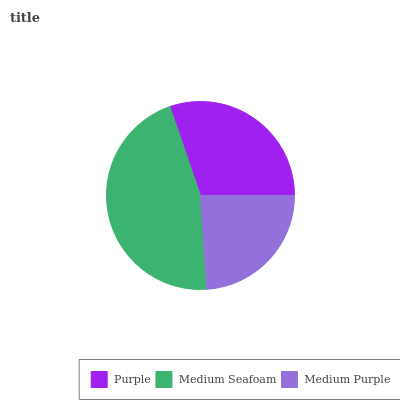Is Medium Purple the minimum?
Answer yes or no. Yes. Is Medium Seafoam the maximum?
Answer yes or no. Yes. Is Medium Seafoam the minimum?
Answer yes or no. No. Is Medium Purple the maximum?
Answer yes or no. No. Is Medium Seafoam greater than Medium Purple?
Answer yes or no. Yes. Is Medium Purple less than Medium Seafoam?
Answer yes or no. Yes. Is Medium Purple greater than Medium Seafoam?
Answer yes or no. No. Is Medium Seafoam less than Medium Purple?
Answer yes or no. No. Is Purple the high median?
Answer yes or no. Yes. Is Purple the low median?
Answer yes or no. Yes. Is Medium Purple the high median?
Answer yes or no. No. Is Medium Purple the low median?
Answer yes or no. No. 